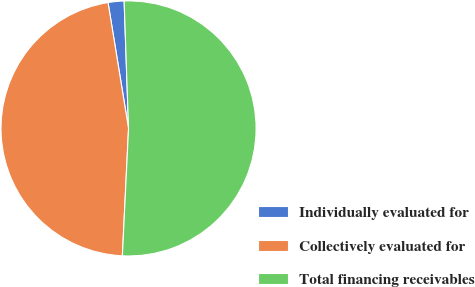Convert chart to OTSL. <chart><loc_0><loc_0><loc_500><loc_500><pie_chart><fcel>Individually evaluated for<fcel>Collectively evaluated for<fcel>Total financing receivables<nl><fcel>2.02%<fcel>46.66%<fcel>51.32%<nl></chart> 